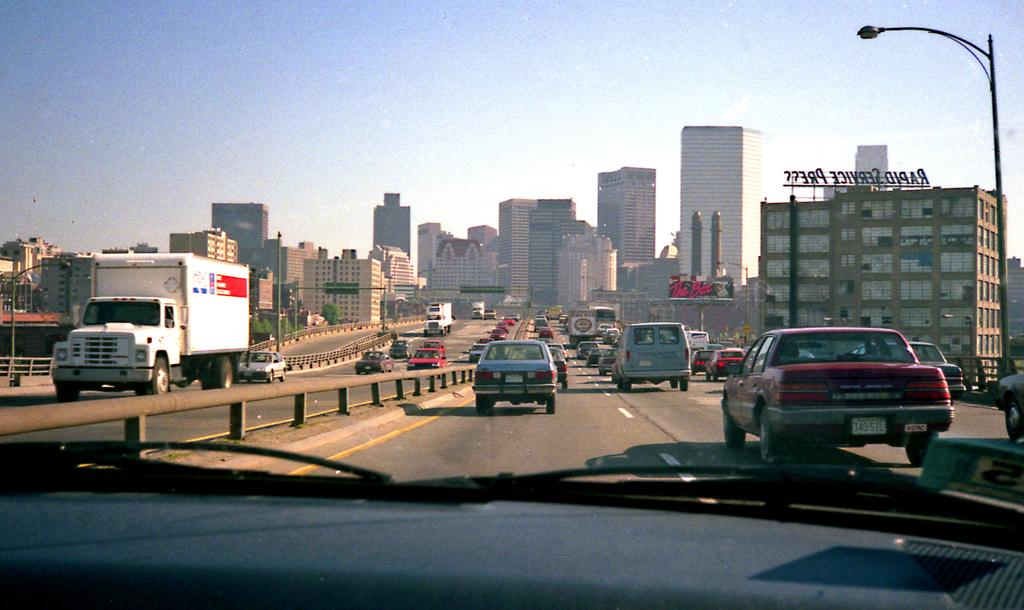What can be seen on the road in the image? There are vehicles on the road in the image. What is the purpose of the railing in the image? The railing in the image is likely for safety or to prevent people or vehicles from going beyond a certain point. What type of structures are visible in the image? There are buildings in the image. What is used to illuminate the road at night in the image? Street lights are present in the image. What is visible in the background of the image? The sky is visible in the image. What type of arch can be seen in the image? There is no arch present in the image. How does the image demonstrate good acoustics? The image does not demonstrate acoustics, as it is a visual representation and not an audio one. 